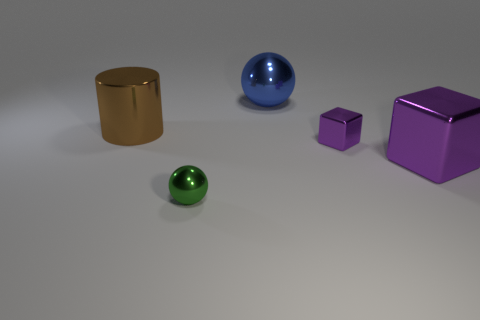There is a large object left of the metallic ball right of the tiny green object; is there a brown shiny cylinder in front of it?
Make the answer very short. No. Is the shape of the purple object that is in front of the tiny purple metallic thing the same as the tiny metallic thing that is to the right of the big blue shiny ball?
Ensure brevity in your answer.  Yes. What color is the large sphere that is made of the same material as the brown object?
Your answer should be very brief. Blue. Are there fewer big brown metallic things in front of the green sphere than tiny cubes?
Offer a very short reply. Yes. There is a sphere that is behind the large thing left of the metal ball that is to the right of the tiny ball; what size is it?
Your answer should be compact. Large. Are the purple thing that is on the right side of the tiny purple object and the blue sphere made of the same material?
Your answer should be compact. Yes. What material is the small cube that is the same color as the big block?
Make the answer very short. Metal. Is there anything else that has the same shape as the tiny purple object?
Your answer should be compact. Yes. How many objects are big blue things or purple cubes?
Give a very brief answer. 3. There is another thing that is the same shape as the big blue thing; what size is it?
Provide a short and direct response. Small. 